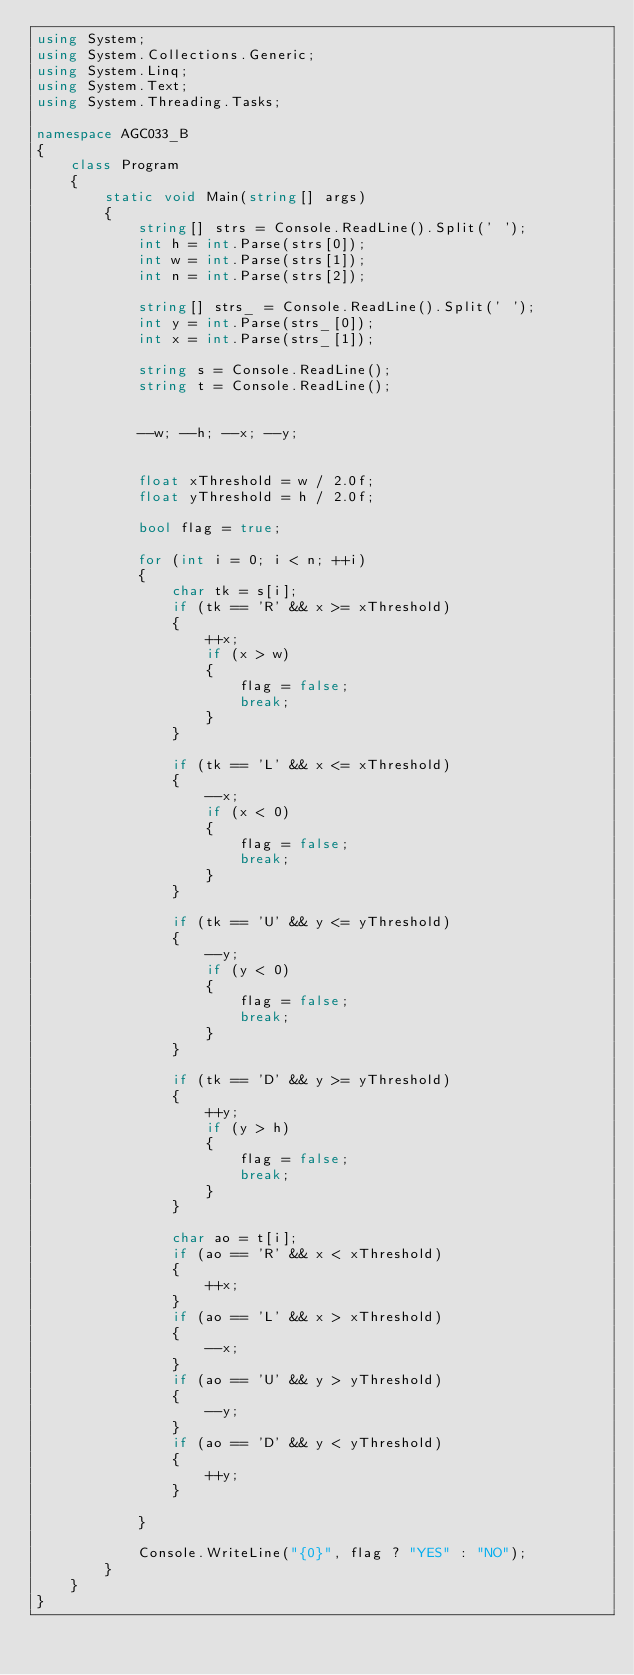<code> <loc_0><loc_0><loc_500><loc_500><_C#_>using System;
using System.Collections.Generic;
using System.Linq;
using System.Text;
using System.Threading.Tasks;

namespace AGC033_B
{
    class Program
    {
        static void Main(string[] args)
        {
            string[] strs = Console.ReadLine().Split(' ');
            int h = int.Parse(strs[0]);
            int w = int.Parse(strs[1]);
            int n = int.Parse(strs[2]);

            string[] strs_ = Console.ReadLine().Split(' ');
            int y = int.Parse(strs_[0]);
            int x = int.Parse(strs_[1]);

            string s = Console.ReadLine();
            string t = Console.ReadLine();


            --w; --h; --x; --y;


            float xThreshold = w / 2.0f;
            float yThreshold = h / 2.0f;

            bool flag = true;

            for (int i = 0; i < n; ++i)
            {
                char tk = s[i];
                if (tk == 'R' && x >= xThreshold)
                {
                    ++x;
                    if (x > w)
                    {
                        flag = false;
                        break;
                    }
                }

                if (tk == 'L' && x <= xThreshold)
                {
                    --x;
                    if (x < 0)
                    {
                        flag = false;
                        break;
                    }
                }

                if (tk == 'U' && y <= yThreshold)
                {
                    --y;
                    if (y < 0)
                    {
                        flag = false;
                        break;
                    }
                }

                if (tk == 'D' && y >= yThreshold)
                {
                    ++y;
                    if (y > h)
                    {
                        flag = false;
                        break;
                    }
                }

                char ao = t[i];
                if (ao == 'R' && x < xThreshold)
                {
                    ++x;
                }
                if (ao == 'L' && x > xThreshold)
                {
                    --x;
                }
                if (ao == 'U' && y > yThreshold)
                {
                    --y;
                }
                if (ao == 'D' && y < yThreshold)
                {
                    ++y;
                }

            }

            Console.WriteLine("{0}", flag ? "YES" : "NO");
        }
    }
}
</code> 